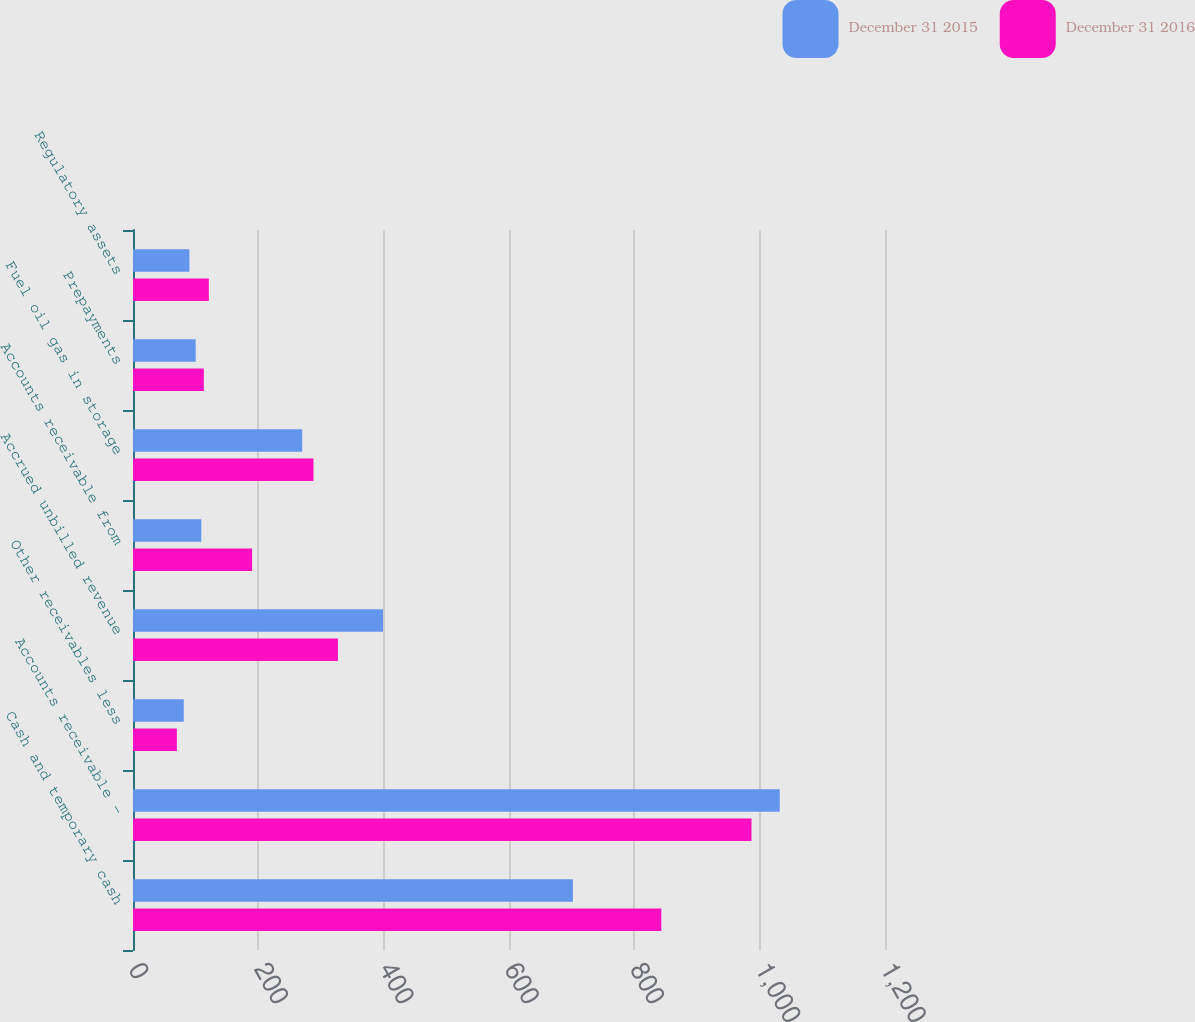Convert chart. <chart><loc_0><loc_0><loc_500><loc_500><stacked_bar_chart><ecel><fcel>Cash and temporary cash<fcel>Accounts receivable -<fcel>Other receivables less<fcel>Accrued unbilled revenue<fcel>Accounts receivable from<fcel>Fuel oil gas in storage<fcel>Prepayments<fcel>Regulatory assets<nl><fcel>December 31 2015<fcel>702<fcel>1032<fcel>81<fcel>399<fcel>109<fcel>270<fcel>100<fcel>90<nl><fcel>December 31 2016<fcel>843<fcel>987<fcel>70<fcel>327<fcel>190<fcel>288<fcel>113<fcel>121<nl></chart> 